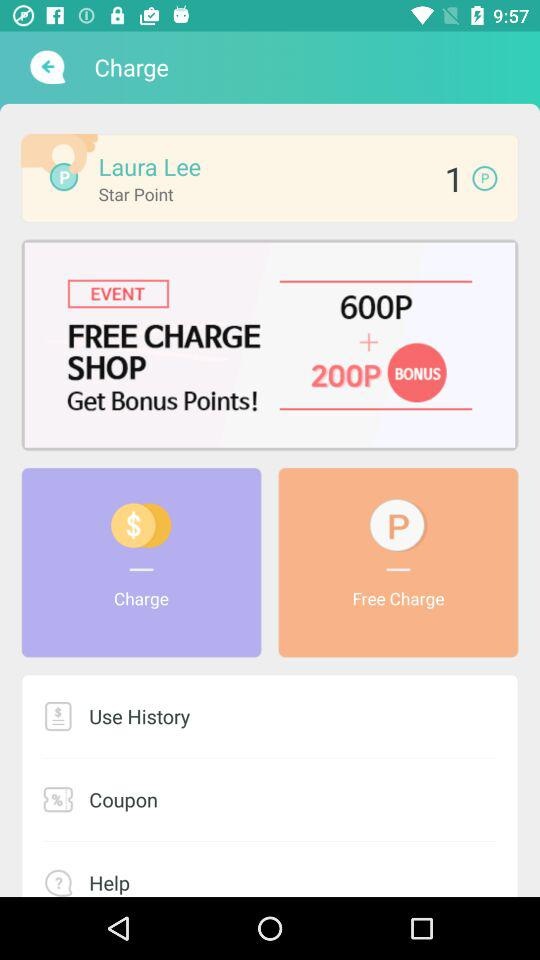How many star points are there? There is 1 star point. 